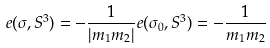Convert formula to latex. <formula><loc_0><loc_0><loc_500><loc_500>e ( \sigma , S ^ { 3 } ) = - \frac { 1 } { | m _ { 1 } m _ { 2 } | } e ( \sigma _ { 0 } , S ^ { 3 } ) = - \frac { 1 } { m _ { 1 } m _ { 2 } }</formula> 